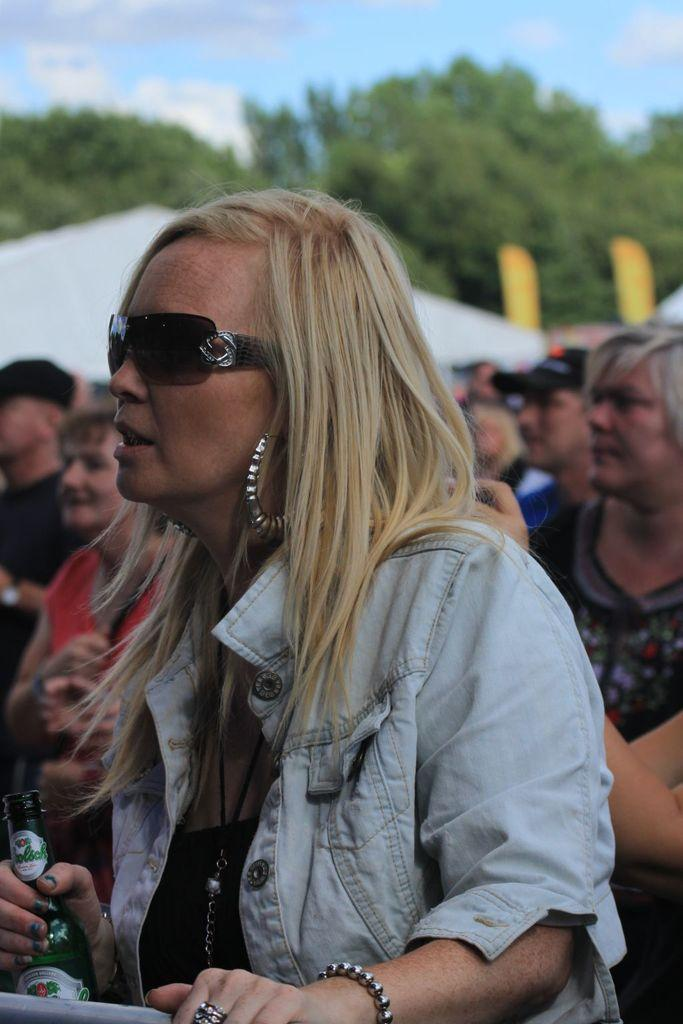How many people are in the image? There are people in the image, but the exact number is not specified. What are some people doing in the image? Some people are holding objects in the image. What type of natural vegetation can be seen in the image? There are trees in the image. What type of man-made structures can be seen in the image? There are houses in the image. What is visible in the background of the image? The sky is visible in the background of the image. What can be observed in the sky? Clouds are present in the sky. How many bottles are being cut by the scissors in the image? There are no bottles or scissors present in the image. What type of flock is flying over the houses in the image? There is no flock of any kind visible in the image. 